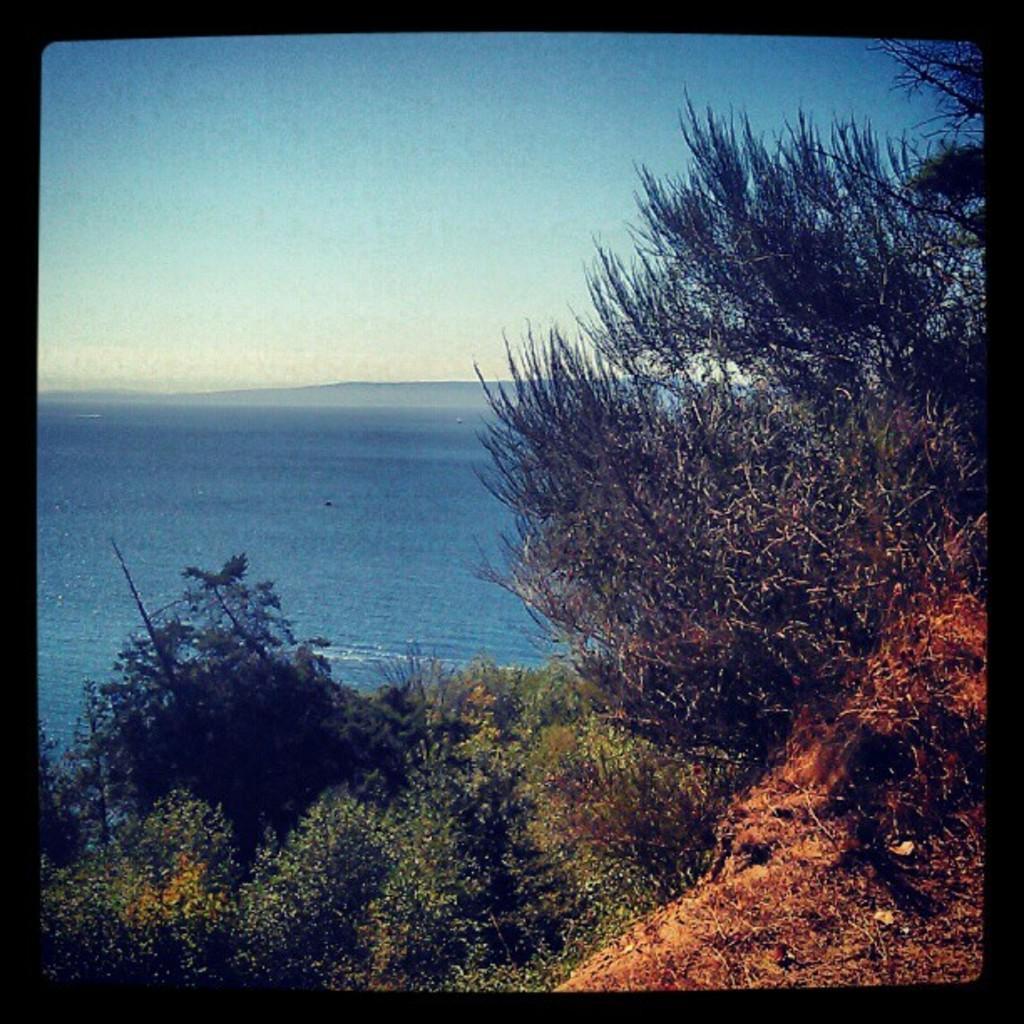Could you give a brief overview of what you see in this image? This image is taken outdoors. At the top of the image there is a sky. in the middle of the image there is sea. At the bottom of the image there are a few plants on the ground. 